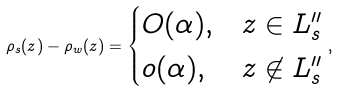Convert formula to latex. <formula><loc_0><loc_0><loc_500><loc_500>\rho _ { s } ( z ) - \rho _ { w } ( z ) = \begin{cases} O ( \alpha ) , & z \in L ^ { \prime \prime } _ { s } \\ o ( \alpha ) , & z \not \in L ^ { \prime \prime } _ { s } \end{cases} ,</formula> 